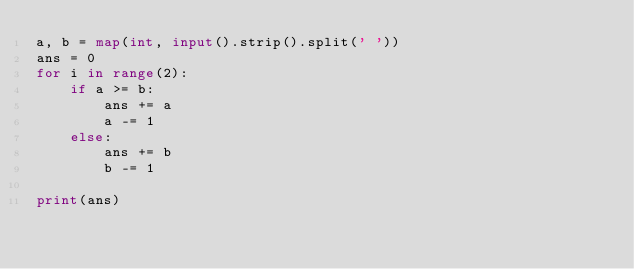Convert code to text. <code><loc_0><loc_0><loc_500><loc_500><_Python_>a, b = map(int, input().strip().split(' '))
ans = 0
for i in range(2):
    if a >= b:
        ans += a
        a -= 1
    else:
        ans += b
        b -= 1

print(ans)</code> 